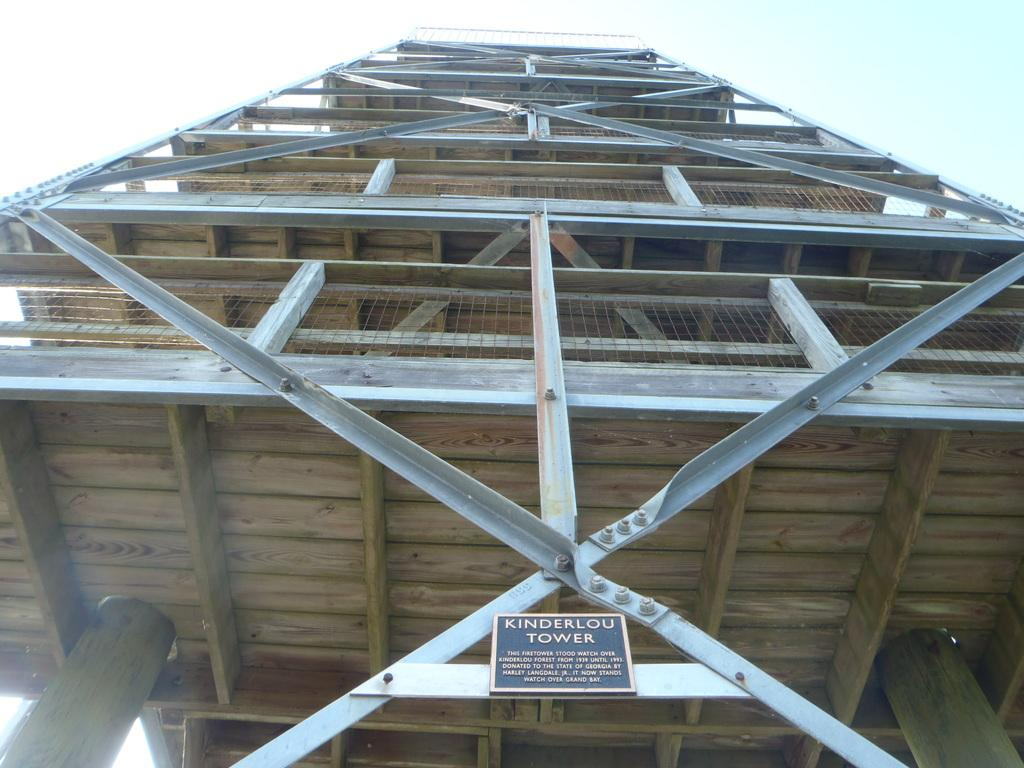What is the main structure visible in the image? There is a tower in the image. What other object can be seen in the image? There is a name board in the image. What happens to the tower when it bursts in the image? There is no indication in the image that the tower bursts, so this question cannot be answered. 